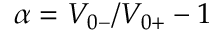Convert formula to latex. <formula><loc_0><loc_0><loc_500><loc_500>\alpha = V _ { 0 - } / V _ { 0 + } - 1</formula> 